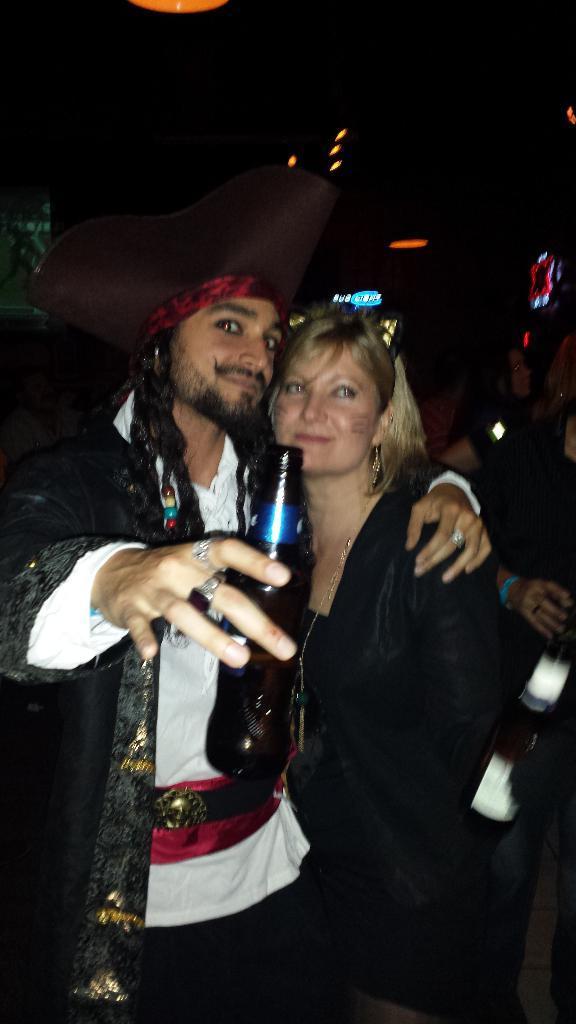How would you summarize this image in a sentence or two? In front of the image there is a person holding the bottle. Beside him there is another person. Behind them there are a few other people. In the background of the image there are display boards. At the top of the image there are lights. 